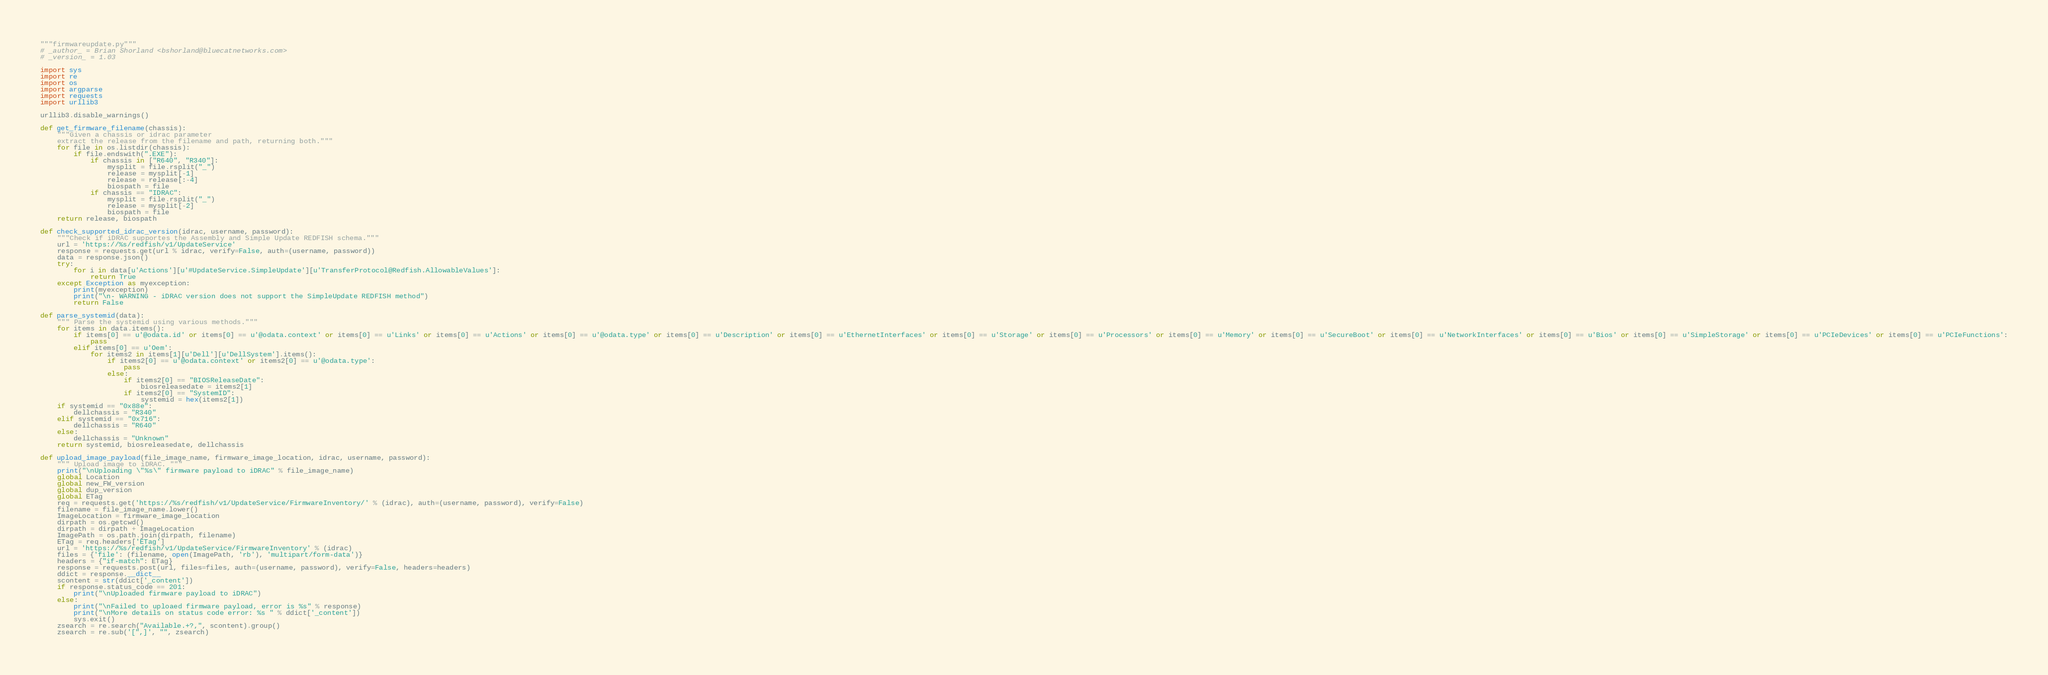Convert code to text. <code><loc_0><loc_0><loc_500><loc_500><_Python_>"""firmwareupdate.py"""
# _author_ = Brian Shorland <bshorland@bluecatnetworks.com>
# _version_ = 1.03

import sys
import re
import os
import argparse
import requests
import urllib3

urllib3.disable_warnings()

def get_firmware_filename(chassis):
    """Given a chassis or idrac parameter
    extract the release from the filename and path, returning both."""
    for file in os.listdir(chassis):
        if file.endswith(".EXE"):
            if chassis in ["R640", "R340"]:
                mysplit = file.rsplit("_")
                release = mysplit[-1]
                release = release[:-4]
                biospath = file
            if chassis == "IDRAC":
                mysplit = file.rsplit("_")
                release = mysplit[-2]
                biospath = file
    return release, biospath

def check_supported_idrac_version(idrac, username, password):
    """Check if iDRAC supportes the Assembly and Simple Update REDFISH schema."""
    url = 'https://%s/redfish/v1/UpdateService'
    response = requests.get(url % idrac, verify=False, auth=(username, password))
    data = response.json()
    try:
        for i in data[u'Actions'][u'#UpdateService.SimpleUpdate'][u'TransferProtocol@Redfish.AllowableValues']:
            return True
    except Exception as myexception:
        print(myexception)
        print("\n- WARNING - iDRAC version does not support the SimpleUpdate REDFISH method")
        return False

def parse_systemid(data):
    """ Parse the systemid using various methods."""
    for items in data.items():
        if items[0] == u'@odata.id' or items[0] == u'@odata.context' or items[0] == u'Links' or items[0] == u'Actions' or items[0] == u'@odata.type' or items[0] == u'Description' or items[0] == u'EthernetInterfaces' or items[0] == u'Storage' or items[0] == u'Processors' or items[0] == u'Memory' or items[0] == u'SecureBoot' or items[0] == u'NetworkInterfaces' or items[0] == u'Bios' or items[0] == u'SimpleStorage' or items[0] == u'PCIeDevices' or items[0] == u'PCIeFunctions':
            pass
        elif items[0] == u'Oem':
            for items2 in items[1][u'Dell'][u'DellSystem'].items():
                if items2[0] == u'@odata.context' or items2[0] == u'@odata.type':
                    pass
                else:
                    if items2[0] == "BIOSReleaseDate":
                        biosreleasedate = items2[1]
                    if items2[0] == "SystemID":
                        systemid = hex(items2[1])
    if systemid == "0x88e":
        dellchassis = "R340"
    elif systemid == "0x716":
        dellchassis = "R640"
    else:
        dellchassis = "Unknown"
    return systemid, biosreleasedate, dellchassis

def upload_image_payload(file_image_name, firmware_image_location, idrac, username, password):
    """ Upload image to iDRAC. """
    print("\nUploading \"%s\" firmware payload to iDRAC" % file_image_name)
    global Location
    global new_FW_version
    global dup_version
    global ETag
    req = requests.get('https://%s/redfish/v1/UpdateService/FirmwareInventory/' % (idrac), auth=(username, password), verify=False)
    filename = file_image_name.lower()
    ImageLocation = firmware_image_location
    dirpath = os.getcwd()
    dirpath = dirpath + ImageLocation
    ImagePath = os.path.join(dirpath, filename)
    ETag = req.headers['ETag']
    url = 'https://%s/redfish/v1/UpdateService/FirmwareInventory' % (idrac)
    files = {'file': (filename, open(ImagePath, 'rb'), 'multipart/form-data')}
    headers = {"if-match": ETag}
    response = requests.post(url, files=files, auth=(username, password), verify=False, headers=headers)
    ddict = response.__dict__
    scontent = str(ddict['_content'])
    if response.status_code == 201:
        print("\nUploaded firmware payload to iDRAC")
    else:
        print("\nFailed to uploaed firmware payload, error is %s" % response)
        print("\nMore details on status code error: %s " % ddict['_content'])
        sys.exit()
    zsearch = re.search("Available.+?,", scontent).group()
    zsearch = re.sub('[",]', "", zsearch)</code> 